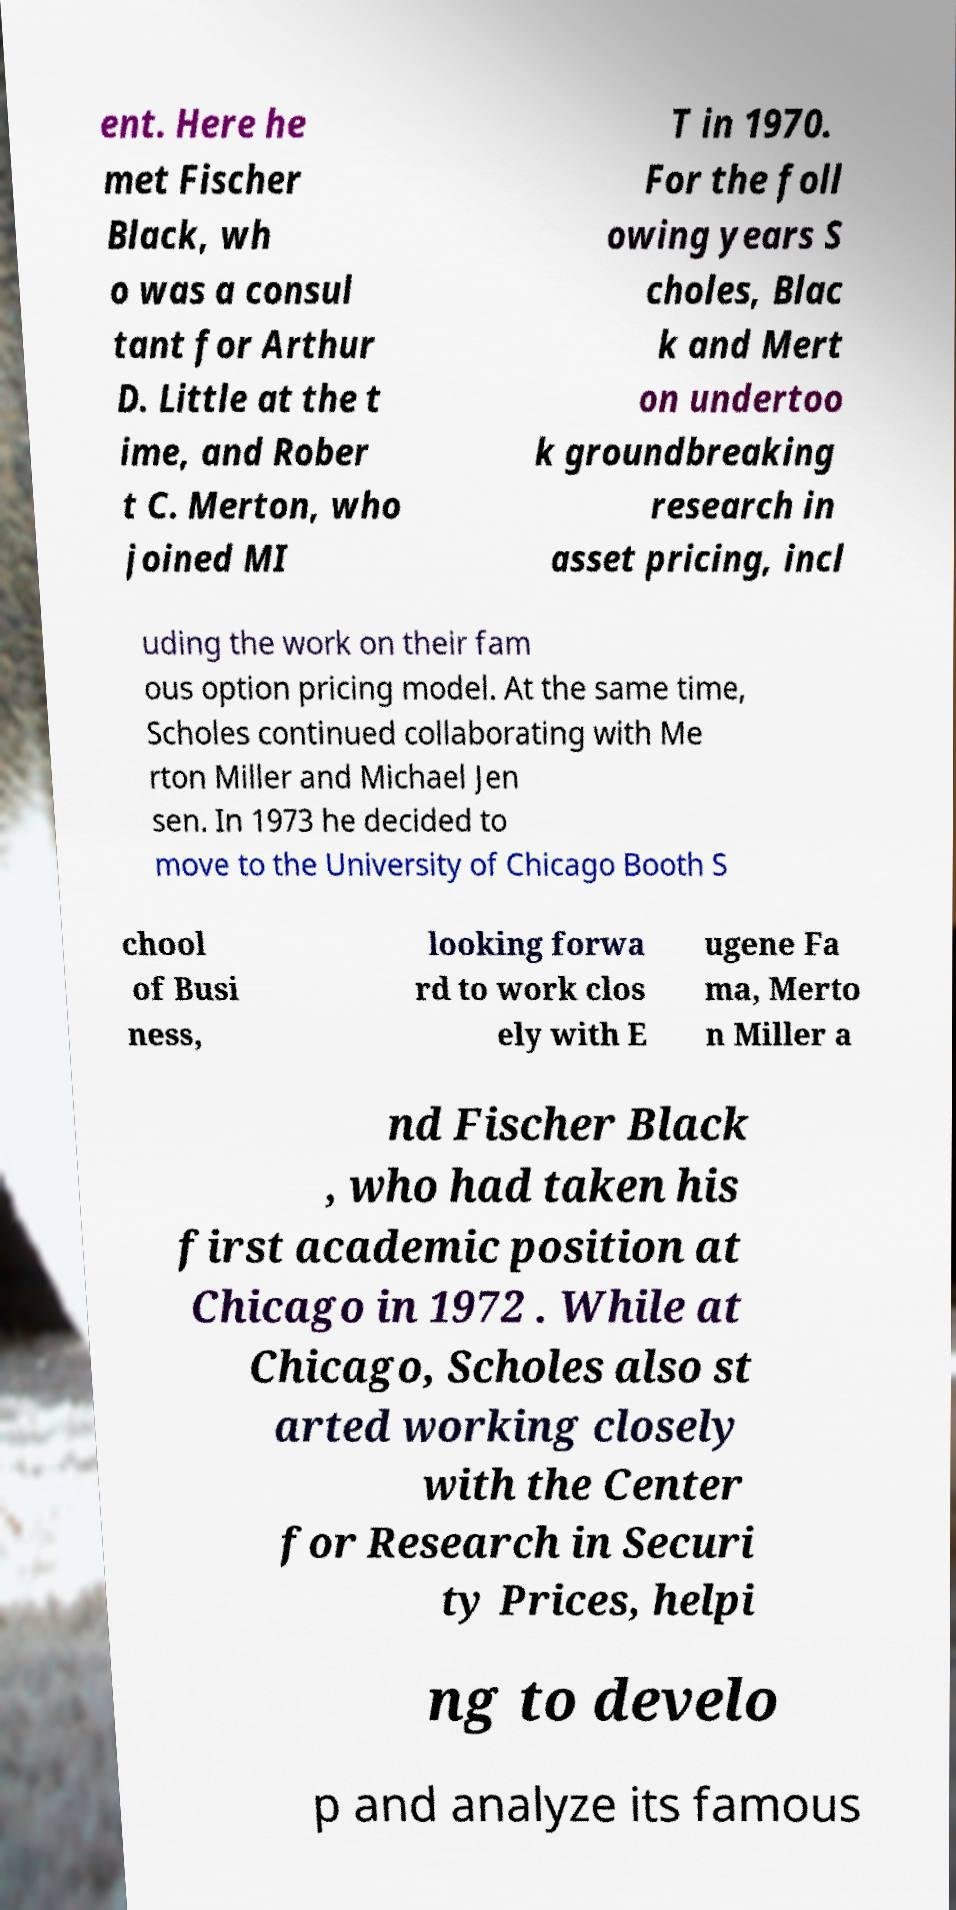Could you assist in decoding the text presented in this image and type it out clearly? ent. Here he met Fischer Black, wh o was a consul tant for Arthur D. Little at the t ime, and Rober t C. Merton, who joined MI T in 1970. For the foll owing years S choles, Blac k and Mert on undertoo k groundbreaking research in asset pricing, incl uding the work on their fam ous option pricing model. At the same time, Scholes continued collaborating with Me rton Miller and Michael Jen sen. In 1973 he decided to move to the University of Chicago Booth S chool of Busi ness, looking forwa rd to work clos ely with E ugene Fa ma, Merto n Miller a nd Fischer Black , who had taken his first academic position at Chicago in 1972 . While at Chicago, Scholes also st arted working closely with the Center for Research in Securi ty Prices, helpi ng to develo p and analyze its famous 